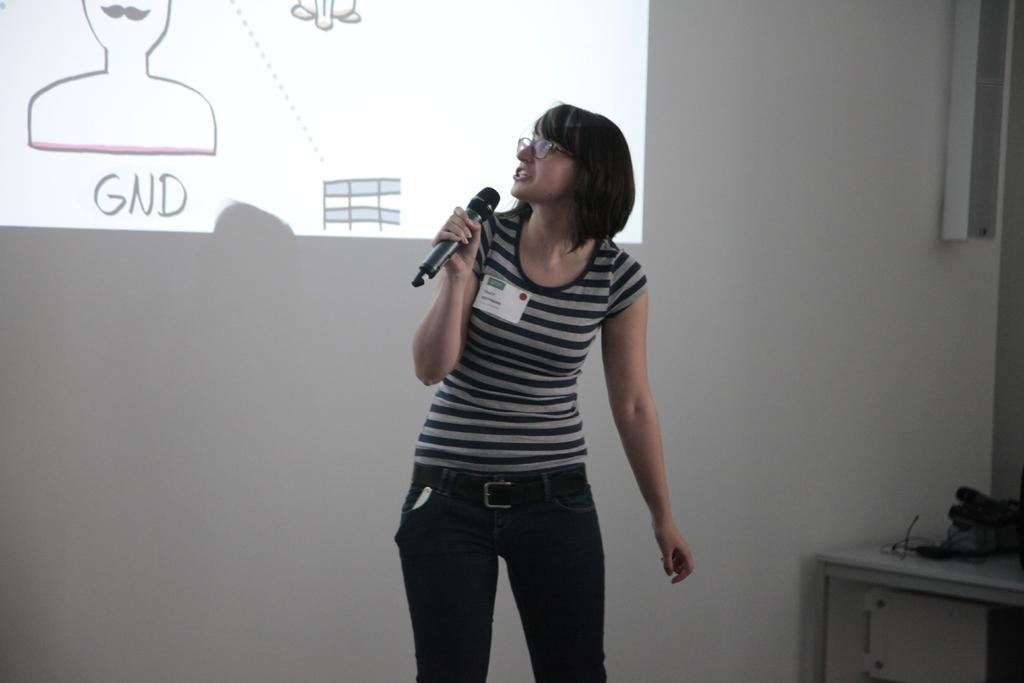Who is the main subject in the image? There is a woman in the image. What is the woman wearing on her face? The woman is wearing spectacles. What is the woman wearing on her clothing? The woman is wearing a badge. What is the woman holding in her hand? The woman is holding a mic. What is the woman doing in the image? The woman is speaking. What can be seen in the background of the image? There is a wall and a screen in the background of the image. What is located on the right side of the image? There is a table on the right side of the image. What type of necklace is the woman wearing in the image? There is no mention of a necklace in the provided facts, so we cannot determine if the woman is wearing one. How many quarters can be seen on the table in the image? There is no mention of quarters or any currency in the provided facts, so we cannot determine if any are present on the table. 